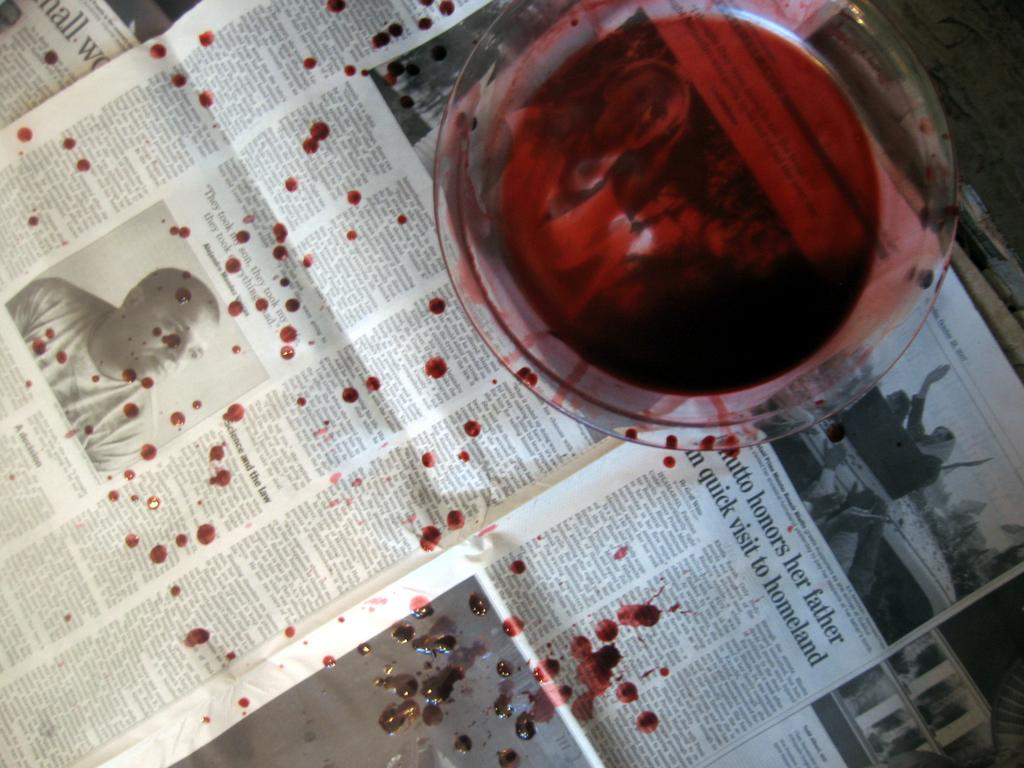<image>
Create a compact narrative representing the image presented. A newspaper article is titled Hutto honors her father in quick visit to homeland. 